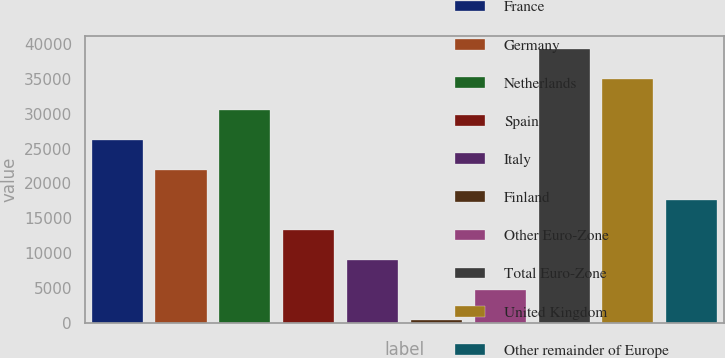Convert chart. <chart><loc_0><loc_0><loc_500><loc_500><bar_chart><fcel>France<fcel>Germany<fcel>Netherlands<fcel>Spain<fcel>Italy<fcel>Finland<fcel>Other Euro-Zone<fcel>Total Euro-Zone<fcel>United Kingdom<fcel>Other remainder of Europe<nl><fcel>26295.2<fcel>21973.5<fcel>30616.9<fcel>13330.1<fcel>9008.4<fcel>365<fcel>4686.7<fcel>39260.3<fcel>34938.6<fcel>17651.8<nl></chart> 